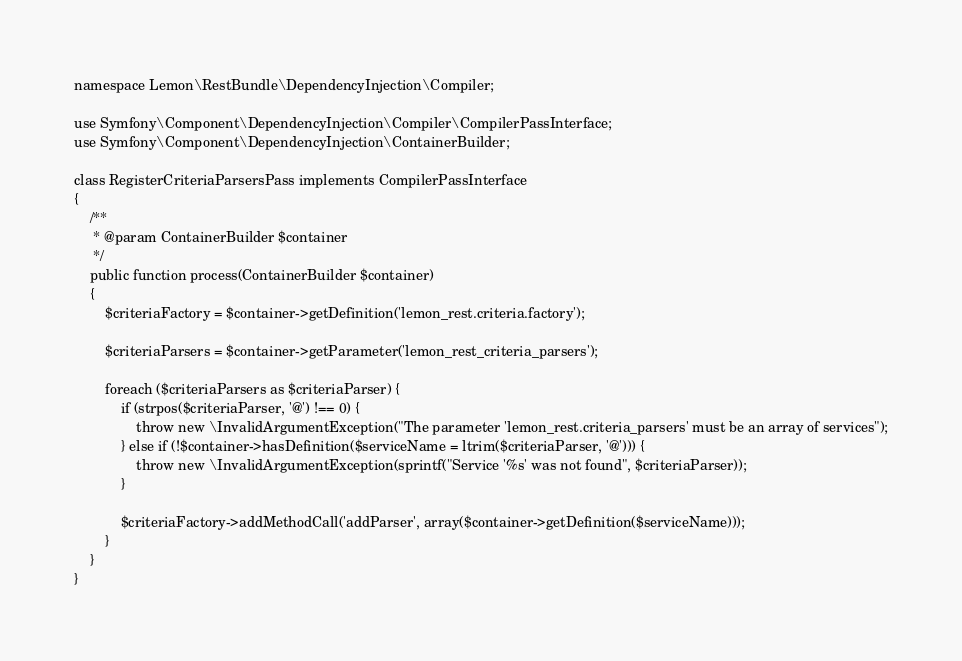<code> <loc_0><loc_0><loc_500><loc_500><_PHP_>namespace Lemon\RestBundle\DependencyInjection\Compiler;

use Symfony\Component\DependencyInjection\Compiler\CompilerPassInterface;
use Symfony\Component\DependencyInjection\ContainerBuilder;

class RegisterCriteriaParsersPass implements CompilerPassInterface
{
    /**
     * @param ContainerBuilder $container
     */
    public function process(ContainerBuilder $container)
    {
        $criteriaFactory = $container->getDefinition('lemon_rest.criteria.factory');

        $criteriaParsers = $container->getParameter('lemon_rest_criteria_parsers');

        foreach ($criteriaParsers as $criteriaParser) {
            if (strpos($criteriaParser, '@') !== 0) {
                throw new \InvalidArgumentException("The parameter 'lemon_rest.criteria_parsers' must be an array of services");
            } else if (!$container->hasDefinition($serviceName = ltrim($criteriaParser, '@'))) {
                throw new \InvalidArgumentException(sprintf("Service '%s' was not found", $criteriaParser));
            }

            $criteriaFactory->addMethodCall('addParser', array($container->getDefinition($serviceName)));
        }
    }
}
</code> 